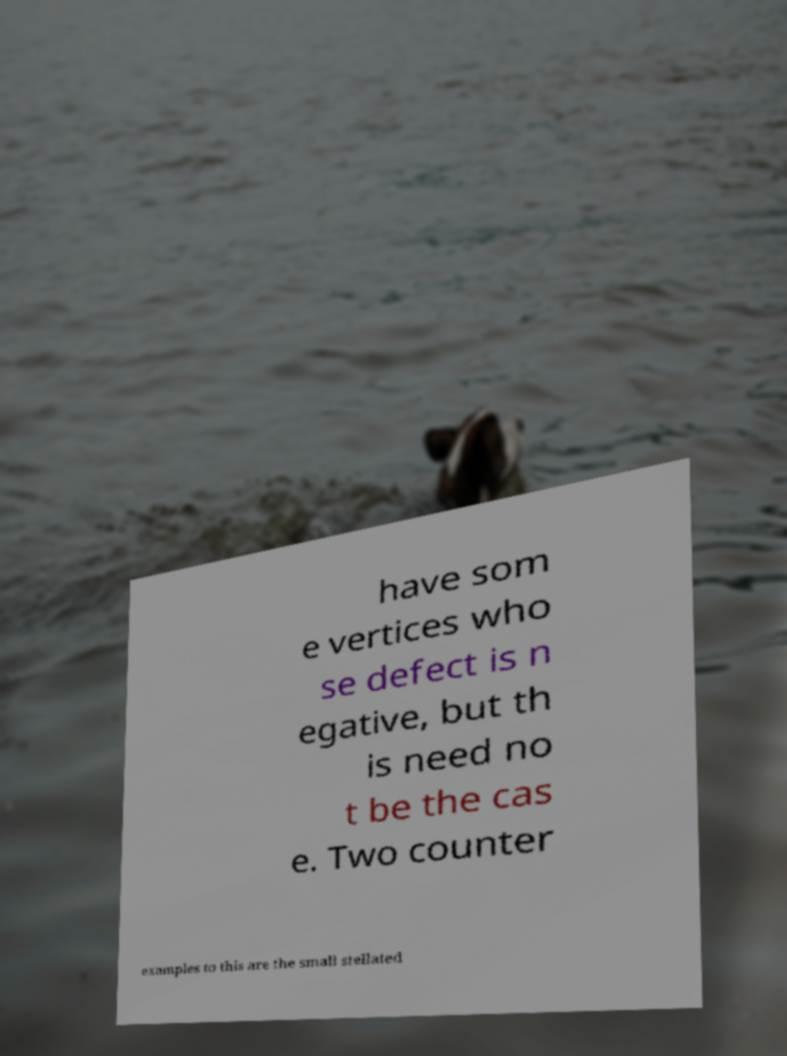I need the written content from this picture converted into text. Can you do that? have som e vertices who se defect is n egative, but th is need no t be the cas e. Two counter examples to this are the small stellated 